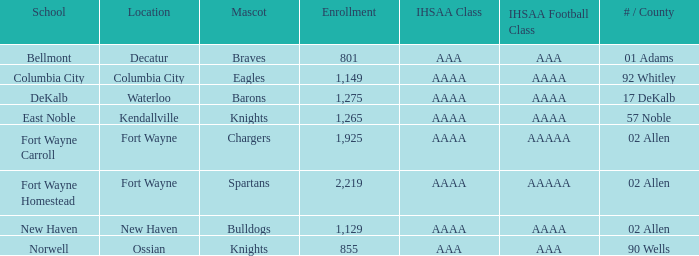What is the ihsaa football class in decatur that has an aaa ihsaa classification? AAA. 